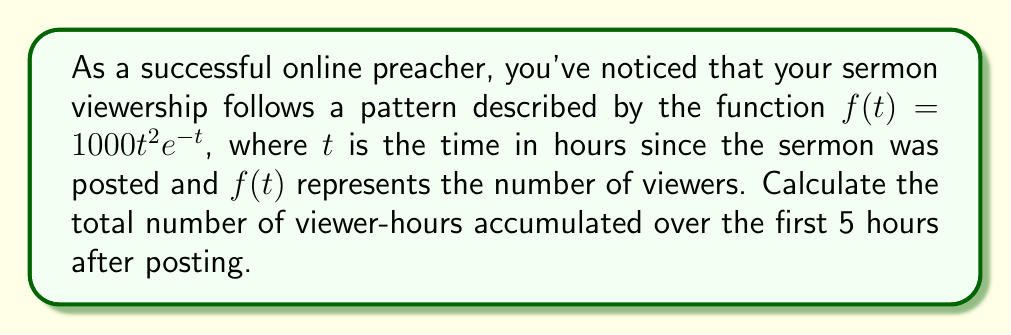Show me your answer to this math problem. To find the total number of viewer-hours, we need to calculate the area under the curve $f(t) = 1000t^2e^{-t}$ from $t=0$ to $t=5$. This can be done using a definite integral:

1) Set up the integral:
   $$\int_0^5 1000t^2e^{-t} dt$$

2) To solve this, we can use integration by parts twice. Let $u = t^2$ and $dv = e^{-t}dt$.

3) First integration by parts:
   $$\int t^2e^{-t} dt = -t^2e^{-t} - \int (-2t)e^{-t} dt$$

4) Second integration by parts (let $u = t$ and $dv = e^{-t}dt$):
   $$-t^2e^{-t} + 2te^{-t} - \int 2e^{-t} dt$$

5) Simplify:
   $$-t^2e^{-t} + 2te^{-t} - 2e^{-t} + C$$

6) Now, apply the limits:
   $$[-t^2e^{-t} + 2te^{-t} - 2e^{-t}]_0^5$$

7) Evaluate at $t=5$:
   $$-25e^{-5} + 10e^{-5} - 2e^{-5} = -17e^{-5}$$

8) Evaluate at $t=0$:
   $$0 + 0 - 2 = -2$$

9) Subtract:
   $$(-17e^{-5}) - (-2) = 2 - 17e^{-5}$$

10) Multiply by 1000 (from the original function):
    $$1000(2 - 17e^{-5}) \approx 1999.57$$

Therefore, the total number of viewer-hours accumulated over the first 5 hours is approximately 1999.57.
Answer: 1999.57 viewer-hours 